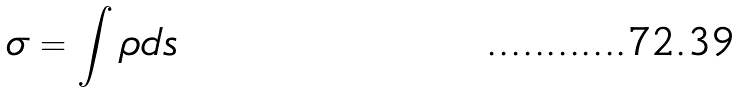<formula> <loc_0><loc_0><loc_500><loc_500>\sigma = \int \rho d s</formula> 